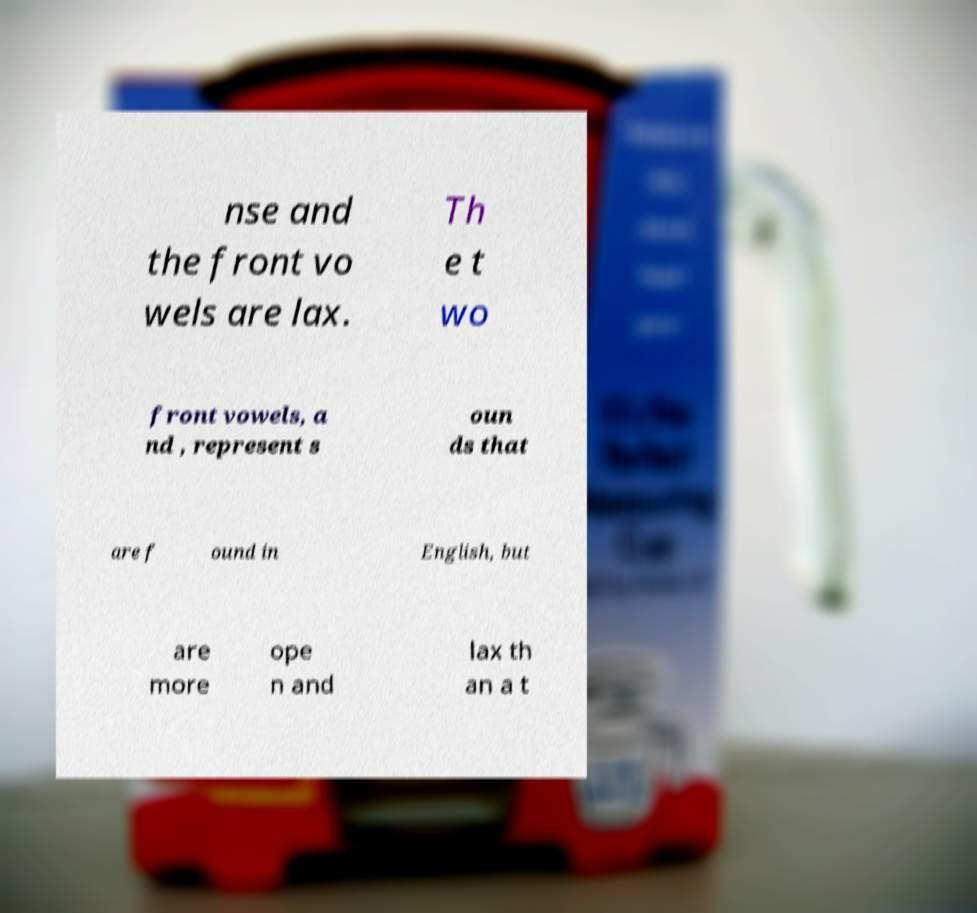Could you extract and type out the text from this image? nse and the front vo wels are lax. Th e t wo front vowels, a nd , represent s oun ds that are f ound in English, but are more ope n and lax th an a t 